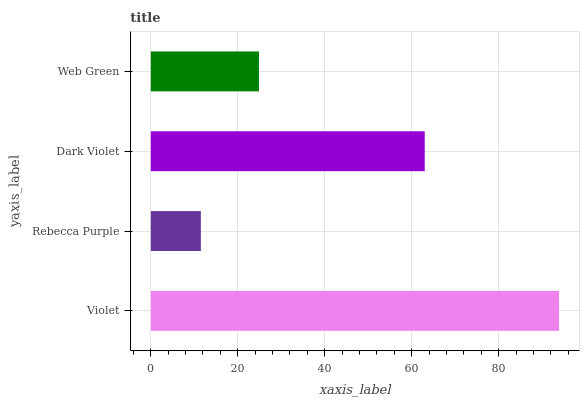Is Rebecca Purple the minimum?
Answer yes or no. Yes. Is Violet the maximum?
Answer yes or no. Yes. Is Dark Violet the minimum?
Answer yes or no. No. Is Dark Violet the maximum?
Answer yes or no. No. Is Dark Violet greater than Rebecca Purple?
Answer yes or no. Yes. Is Rebecca Purple less than Dark Violet?
Answer yes or no. Yes. Is Rebecca Purple greater than Dark Violet?
Answer yes or no. No. Is Dark Violet less than Rebecca Purple?
Answer yes or no. No. Is Dark Violet the high median?
Answer yes or no. Yes. Is Web Green the low median?
Answer yes or no. Yes. Is Web Green the high median?
Answer yes or no. No. Is Violet the low median?
Answer yes or no. No. 